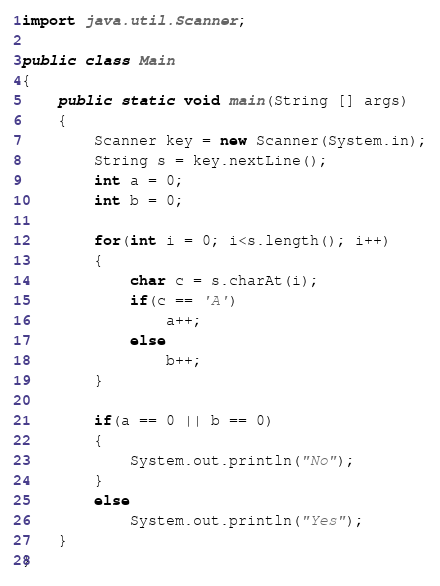Convert code to text. <code><loc_0><loc_0><loc_500><loc_500><_Java_>import java.util.Scanner;

public class Main
{
    public static void main(String [] args)
    {
        Scanner key = new Scanner(System.in);
        String s = key.nextLine();
        int a = 0;
        int b = 0;

        for(int i = 0; i<s.length(); i++)
        {
            char c = s.charAt(i);
            if(c == 'A')
                a++;
            else
                b++;
        }

        if(a == 0 || b == 0)
        {
            System.out.println("No");
        }
        else
            System.out.println("Yes");
    }
}</code> 